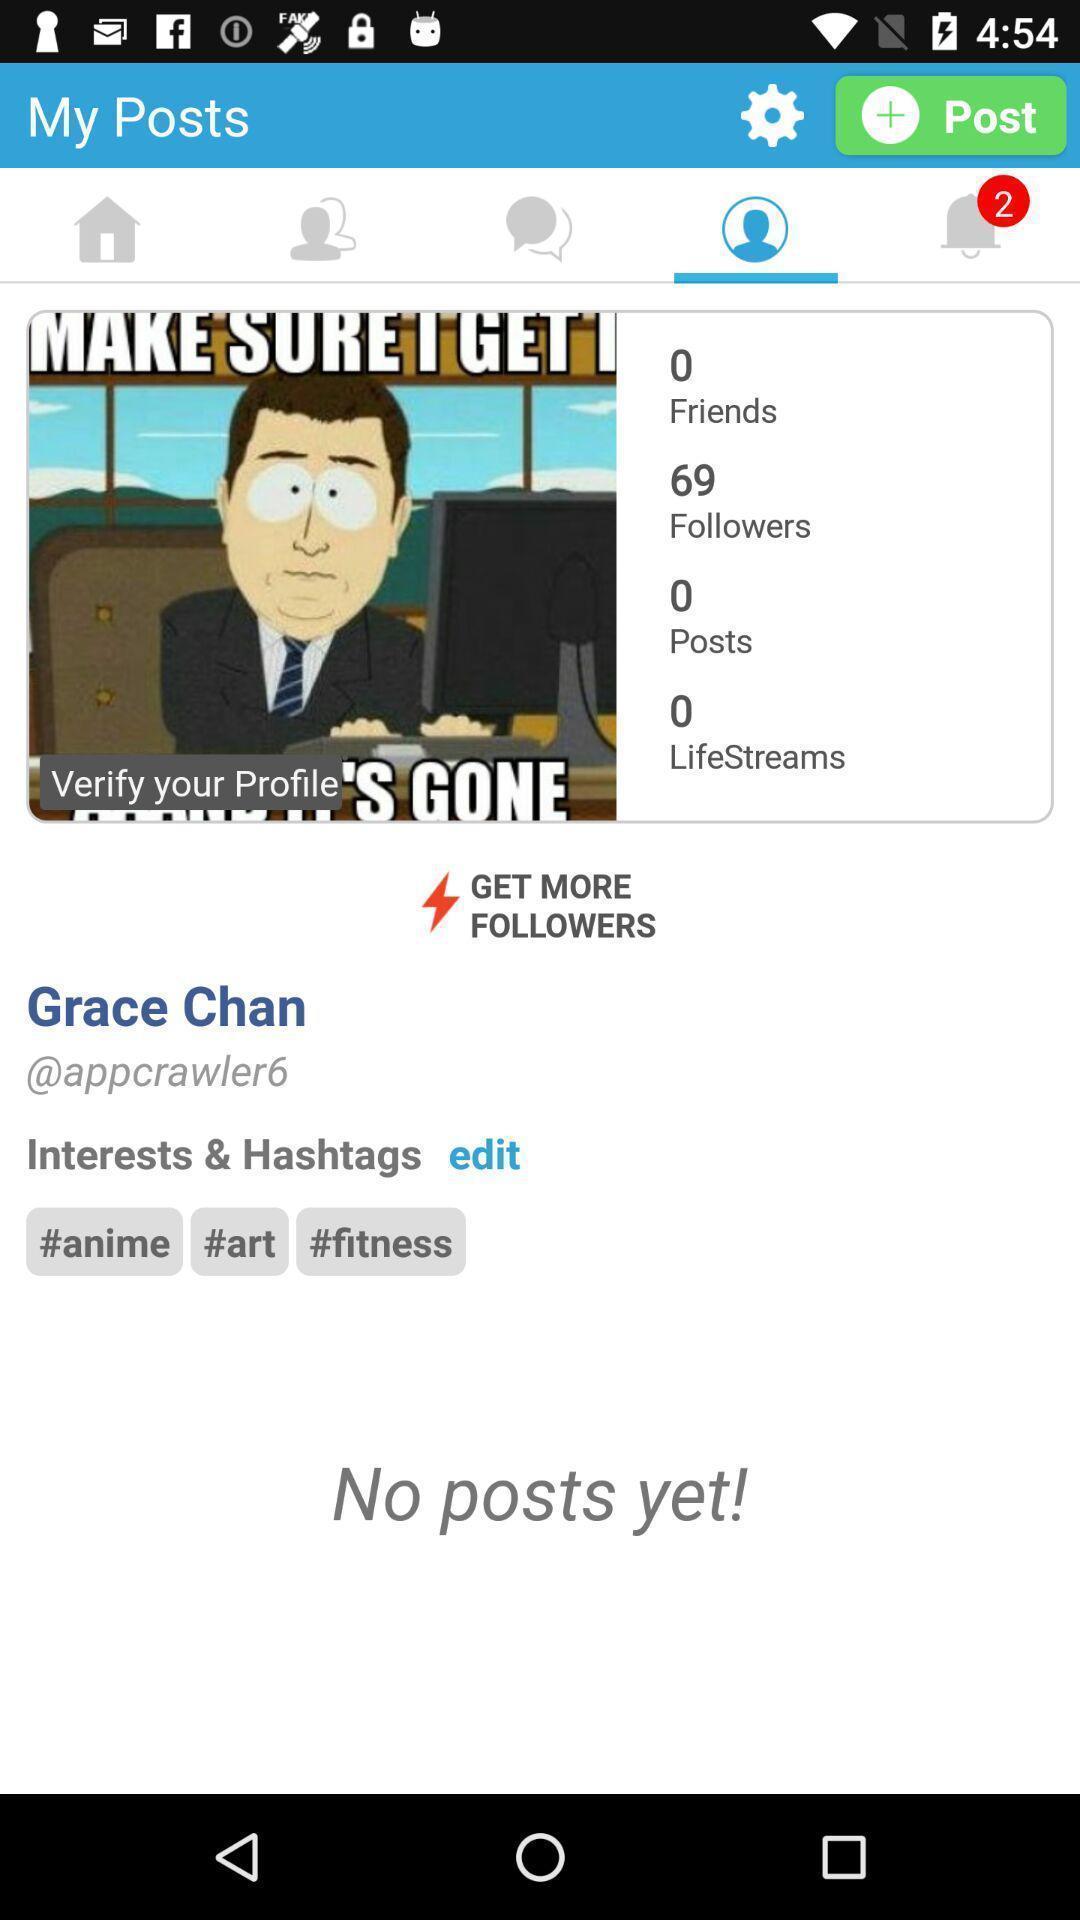Provide a detailed account of this screenshot. Social app displaying profile details. 